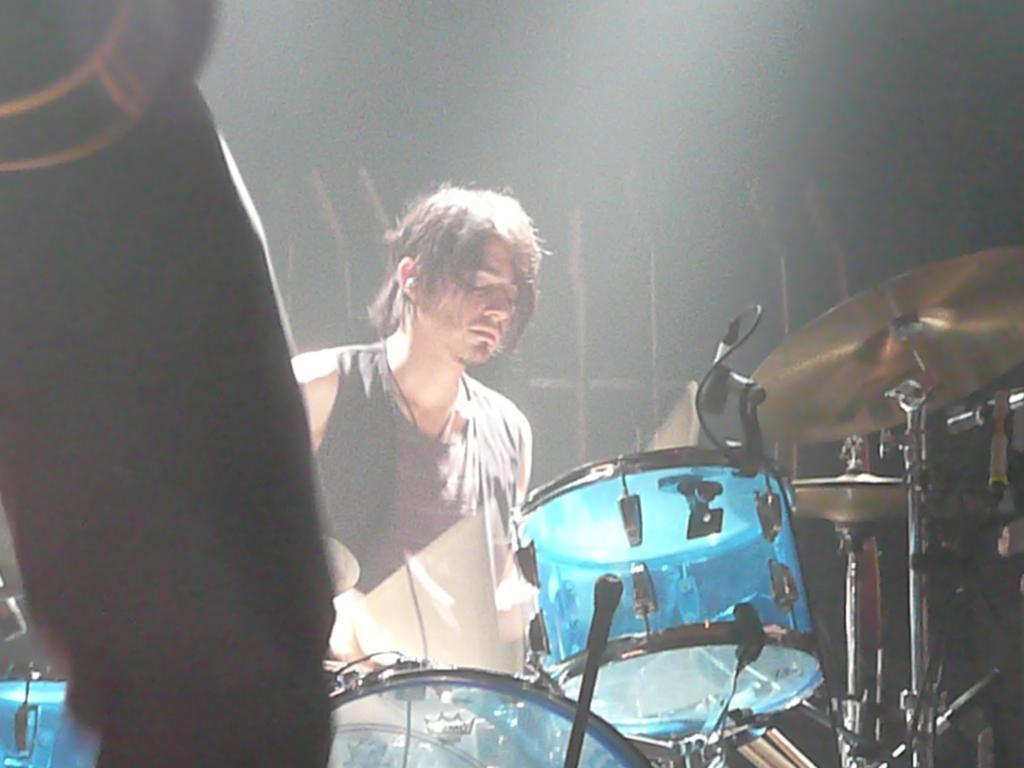What is the main subject of the image? The main subject of the image is a person playing drums. Where is the person playing drums located in the image? The person playing drums is in the middle of the image. Can you describe any other visible body parts in the image? Yes, there is a leg visible on the left side of the image. What type of meat is being served on the card in the image? There is no card or meat present in the image; it features a person playing drums. 